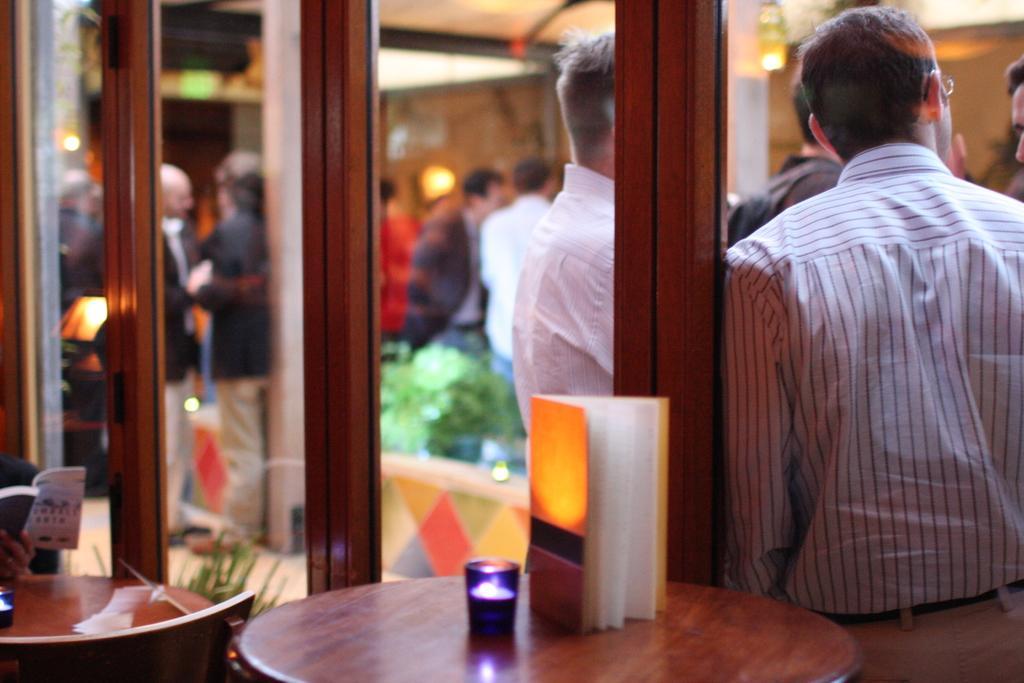Can you describe this image briefly? There is a book on the table and there is a glass door beside it and there are group of people standing beside the glass door. 